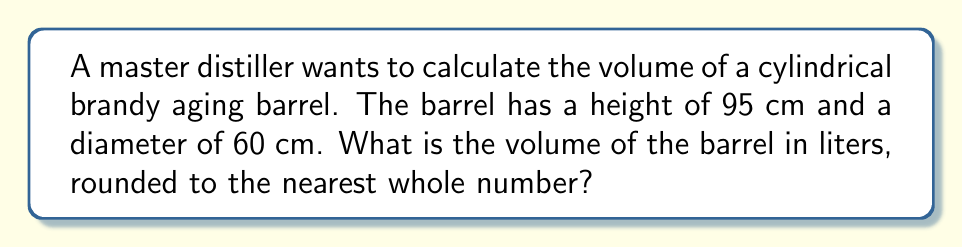Help me with this question. Let's approach this step-by-step:

1) The formula for the volume of a cylinder is:
   $$V = \pi r^2 h$$
   where $r$ is the radius and $h$ is the height.

2) We're given the diameter (60 cm), so we need to calculate the radius:
   $$r = \frac{60}{2} = 30 \text{ cm}$$

3) Now we can substitute the values into our formula:
   $$V = \pi (30 \text{ cm})^2 (95 \text{ cm})$$

4) Let's calculate:
   $$V = \pi (900 \text{ cm}^2) (95 \text{ cm})$$
   $$V = 85,500\pi \text{ cm}^3$$

5) Using $\pi \approx 3.14159$:
   $$V \approx 268,605.95 \text{ cm}^3$$

6) To convert from cm³ to liters, we divide by 1000:
   $$V \approx 268.60595 \text{ liters}$$

7) Rounding to the nearest whole number:
   $$V \approx 269 \text{ liters}$$

This barrel can age quite a lot of brandy!
Answer: 269 liters 